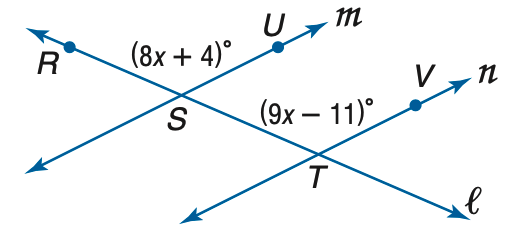Answer the mathemtical geometry problem and directly provide the correct option letter.
Question: Find x so that m \parallel n.
Choices: A: 7 B: 11 C: 15 D: 19 C 